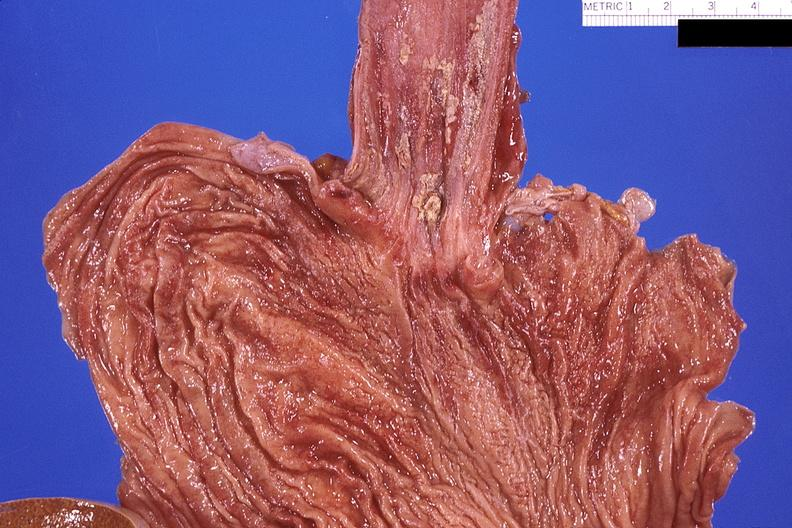what is present?
Answer the question using a single word or phrase. Gastrointestinal 